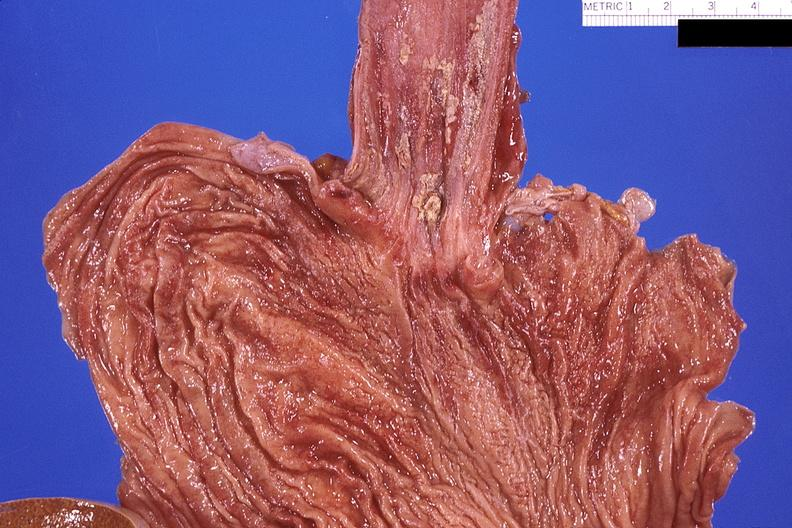what is present?
Answer the question using a single word or phrase. Gastrointestinal 